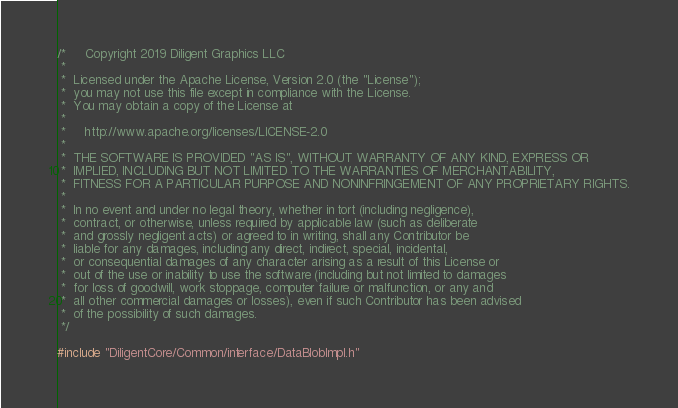<code> <loc_0><loc_0><loc_500><loc_500><_C++_>/*     Copyright 2019 Diligent Graphics LLC
 *  
 *  Licensed under the Apache License, Version 2.0 (the "License");
 *  you may not use this file except in compliance with the License.
 *  You may obtain a copy of the License at
 * 
 *     http://www.apache.org/licenses/LICENSE-2.0
 * 
 *  THE SOFTWARE IS PROVIDED "AS IS", WITHOUT WARRANTY OF ANY KIND, EXPRESS OR
 *  IMPLIED, INCLUDING BUT NOT LIMITED TO THE WARRANTIES OF MERCHANTABILITY,
 *  FITNESS FOR A PARTICULAR PURPOSE AND NONINFRINGEMENT OF ANY PROPRIETARY RIGHTS.
 *
 *  In no event and under no legal theory, whether in tort (including negligence), 
 *  contract, or otherwise, unless required by applicable law (such as deliberate 
 *  and grossly negligent acts) or agreed to in writing, shall any Contributor be
 *  liable for any damages, including any direct, indirect, special, incidental, 
 *  or consequential damages of any character arising as a result of this License or 
 *  out of the use or inability to use the software (including but not limited to damages 
 *  for loss of goodwill, work stoppage, computer failure or malfunction, or any and 
 *  all other commercial damages or losses), even if such Contributor has been advised 
 *  of the possibility of such damages.
 */

#include "DiligentCore/Common/interface/DataBlobImpl.h"
</code> 